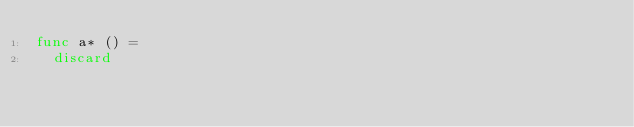<code> <loc_0><loc_0><loc_500><loc_500><_Nim_>func a* () =
  discard
</code> 